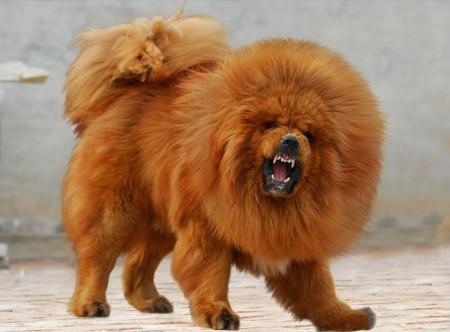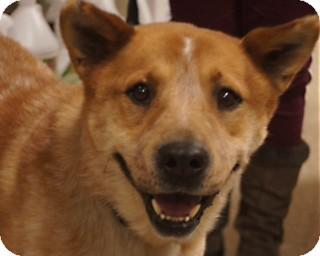The first image is the image on the left, the second image is the image on the right. Assess this claim about the two images: "The dog on the right is clearly a much smaller, shorter animal than the dog on the left.". Correct or not? Answer yes or no. No. 